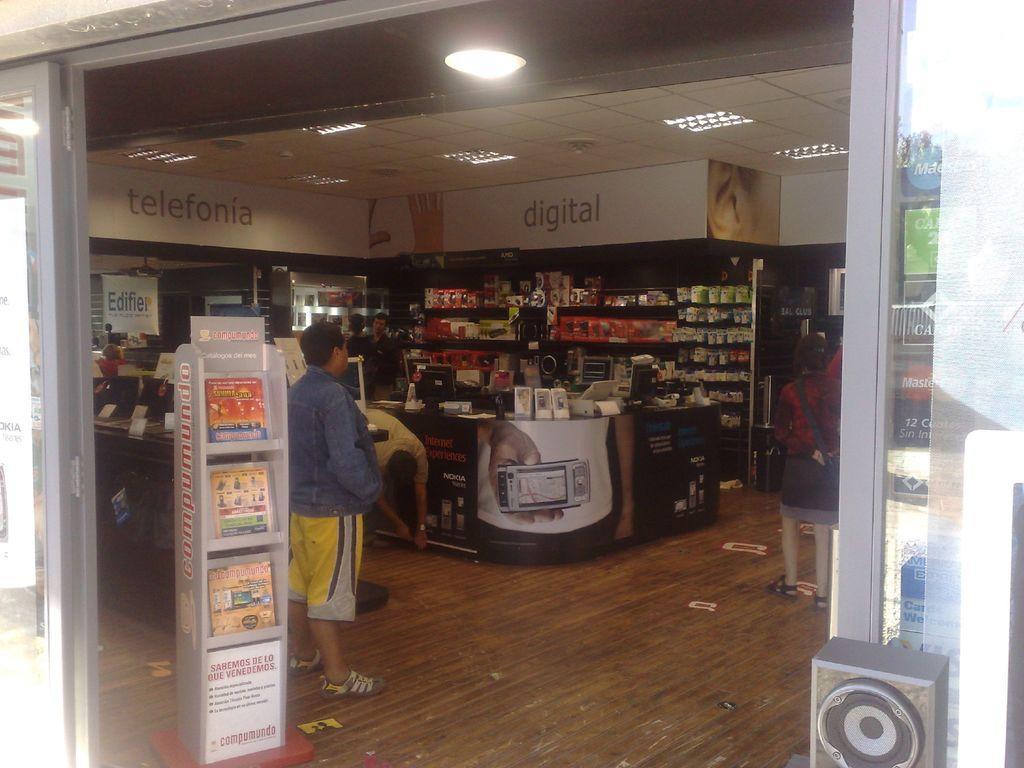How would you summarize this image in a sentence or two? A picture inside of a store. On top there is a light attached to ceiling. These persons are standing. These racks are filled with radio, books and things. On this poster we can able to see a camera. Front there is a speaker. 